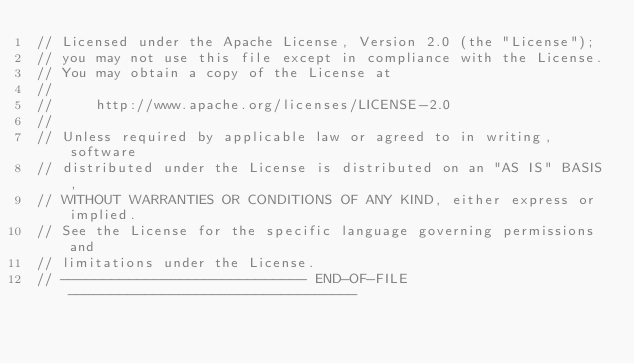Convert code to text. <code><loc_0><loc_0><loc_500><loc_500><_C_>// Licensed under the Apache License, Version 2.0 (the "License");
// you may not use this file except in compliance with the License.
// You may obtain a copy of the License at
//
//     http://www.apache.org/licenses/LICENSE-2.0
//
// Unless required by applicable law or agreed to in writing, software
// distributed under the License is distributed on an "AS IS" BASIS,
// WITHOUT WARRANTIES OR CONDITIONS OF ANY KIND, either express or implied.
// See the License for the specific language governing permissions and
// limitations under the License.
// ----------------------------- END-OF-FILE ----------------------------------
</code> 